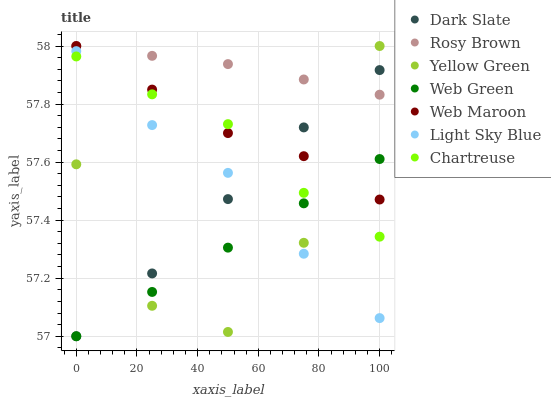Does Web Green have the minimum area under the curve?
Answer yes or no. Yes. Does Rosy Brown have the maximum area under the curve?
Answer yes or no. Yes. Does Web Maroon have the minimum area under the curve?
Answer yes or no. No. Does Web Maroon have the maximum area under the curve?
Answer yes or no. No. Is Web Green the smoothest?
Answer yes or no. Yes. Is Yellow Green the roughest?
Answer yes or no. Yes. Is Rosy Brown the smoothest?
Answer yes or no. No. Is Rosy Brown the roughest?
Answer yes or no. No. Does Web Green have the lowest value?
Answer yes or no. Yes. Does Web Maroon have the lowest value?
Answer yes or no. No. Does Web Maroon have the highest value?
Answer yes or no. Yes. Does Web Green have the highest value?
Answer yes or no. No. Is Light Sky Blue less than Rosy Brown?
Answer yes or no. Yes. Is Rosy Brown greater than Light Sky Blue?
Answer yes or no. Yes. Does Light Sky Blue intersect Dark Slate?
Answer yes or no. Yes. Is Light Sky Blue less than Dark Slate?
Answer yes or no. No. Is Light Sky Blue greater than Dark Slate?
Answer yes or no. No. Does Light Sky Blue intersect Rosy Brown?
Answer yes or no. No. 